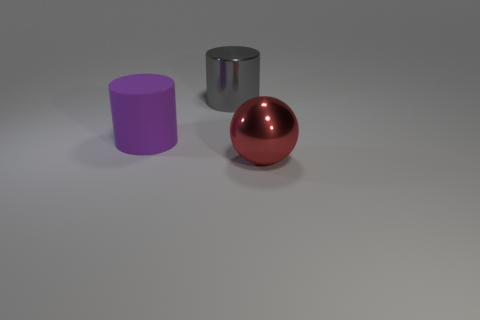Are there the same number of red objects in front of the red metallic sphere and large gray metal cylinders?
Offer a very short reply. No. Is there anything else that is the same material as the big purple object?
Keep it short and to the point. No. There is a large matte object; does it have the same color as the thing behind the big purple matte object?
Offer a terse response. No. There is a metallic thing that is right of the metallic thing behind the large red sphere; are there any cylinders behind it?
Your answer should be very brief. Yes. Is the number of things to the right of the big shiny cylinder less than the number of purple metal blocks?
Your answer should be compact. No. How many other things are there of the same shape as the large red thing?
Offer a very short reply. 0. How many objects are either large shiny objects that are behind the big red metal sphere or metallic things that are behind the big rubber cylinder?
Your answer should be very brief. 1. How big is the thing that is both right of the purple cylinder and on the left side of the large metallic ball?
Offer a terse response. Large. There is a large object on the right side of the large metal cylinder; is it the same shape as the gray shiny thing?
Provide a short and direct response. No. There is a thing that is behind the big cylinder that is in front of the cylinder that is right of the rubber thing; how big is it?
Offer a very short reply. Large. 